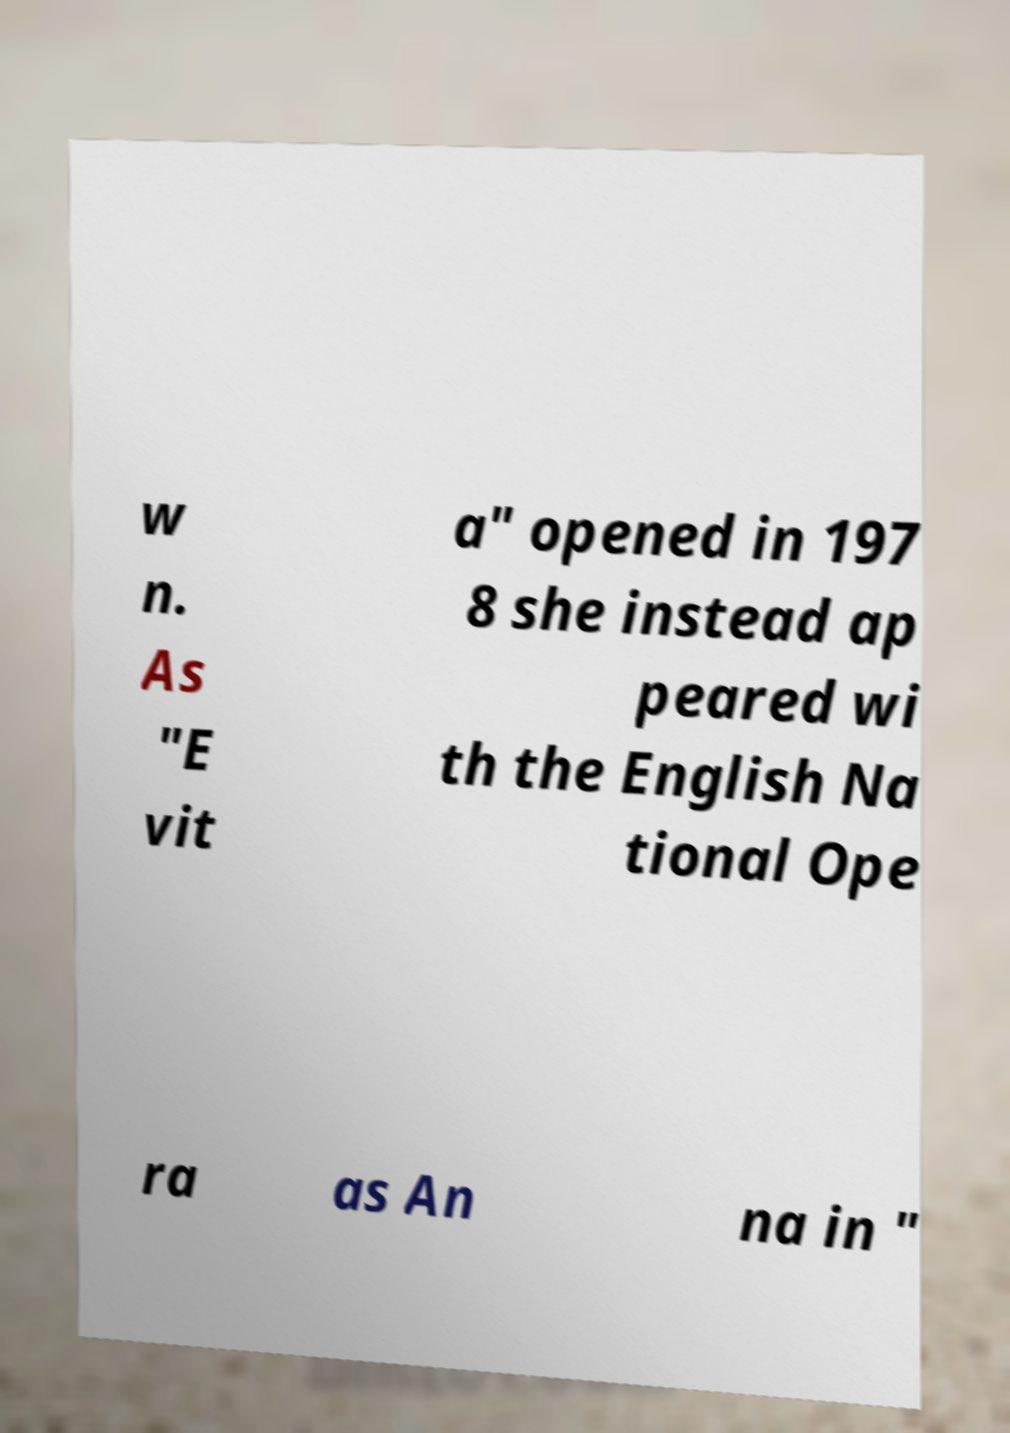What messages or text are displayed in this image? I need them in a readable, typed format. w n. As "E vit a" opened in 197 8 she instead ap peared wi th the English Na tional Ope ra as An na in " 